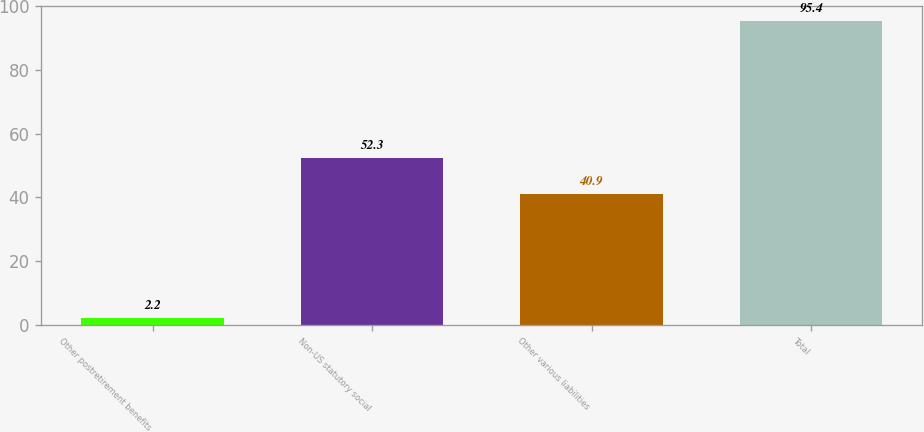<chart> <loc_0><loc_0><loc_500><loc_500><bar_chart><fcel>Other postretirement benefits<fcel>Non-US statutory social<fcel>Other various liabilities<fcel>Total<nl><fcel>2.2<fcel>52.3<fcel>40.9<fcel>95.4<nl></chart> 